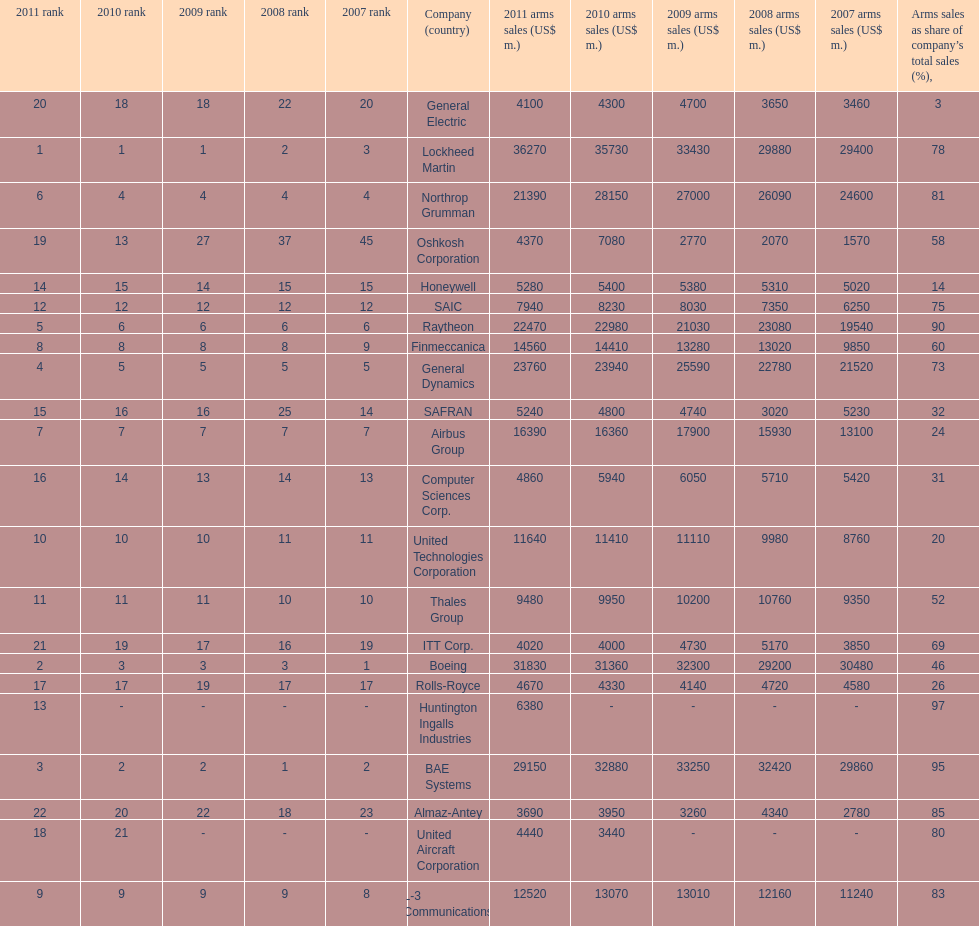Which company had the highest 2009 arms sales? Lockheed Martin. 